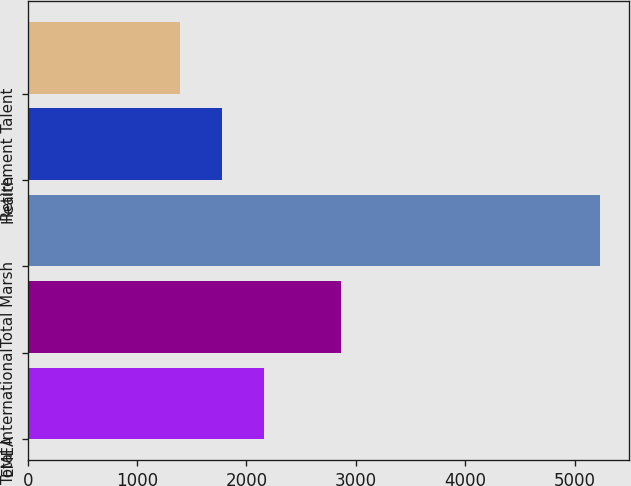Convert chart to OTSL. <chart><loc_0><loc_0><loc_500><loc_500><bar_chart><fcel>EMEA<fcel>Total International<fcel>Total Marsh<fcel>Health<fcel>Retirement Talent<nl><fcel>2163.2<fcel>2869<fcel>5232<fcel>1779.6<fcel>1396<nl></chart> 